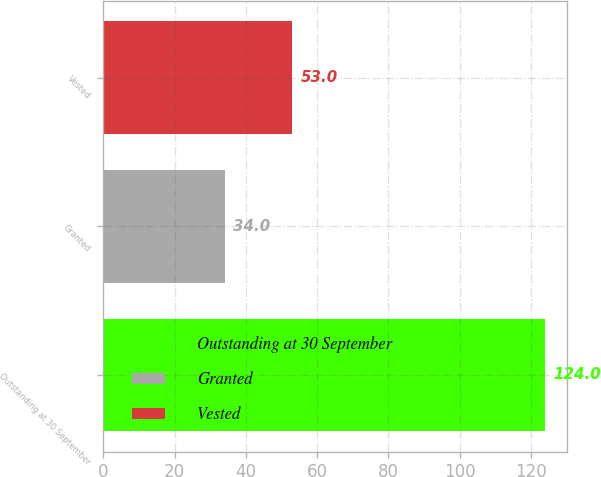Convert chart to OTSL. <chart><loc_0><loc_0><loc_500><loc_500><bar_chart><fcel>Outstanding at 30 September<fcel>Granted<fcel>Vested<nl><fcel>124<fcel>34<fcel>53<nl></chart> 